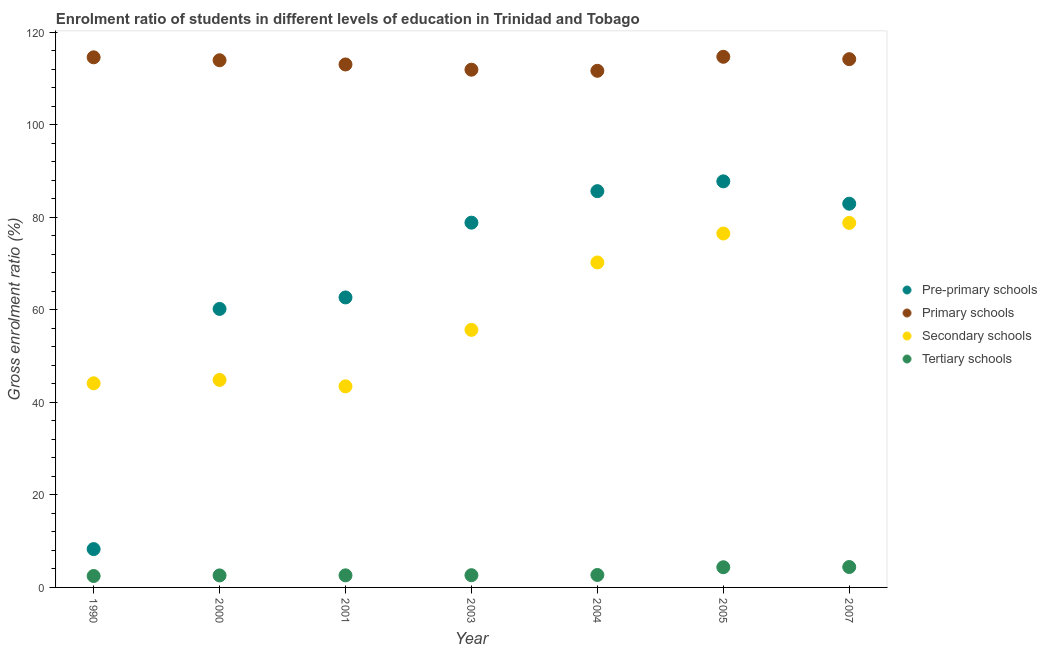How many different coloured dotlines are there?
Ensure brevity in your answer.  4. Is the number of dotlines equal to the number of legend labels?
Ensure brevity in your answer.  Yes. What is the gross enrolment ratio in pre-primary schools in 2001?
Your answer should be very brief. 62.68. Across all years, what is the maximum gross enrolment ratio in primary schools?
Provide a short and direct response. 114.69. Across all years, what is the minimum gross enrolment ratio in pre-primary schools?
Provide a short and direct response. 8.29. In which year was the gross enrolment ratio in tertiary schools maximum?
Give a very brief answer. 2007. In which year was the gross enrolment ratio in secondary schools minimum?
Keep it short and to the point. 2001. What is the total gross enrolment ratio in secondary schools in the graph?
Make the answer very short. 413.62. What is the difference between the gross enrolment ratio in primary schools in 2004 and that in 2007?
Make the answer very short. -2.52. What is the difference between the gross enrolment ratio in tertiary schools in 2001 and the gross enrolment ratio in pre-primary schools in 1990?
Your answer should be very brief. -5.68. What is the average gross enrolment ratio in secondary schools per year?
Provide a short and direct response. 59.09. In the year 2000, what is the difference between the gross enrolment ratio in secondary schools and gross enrolment ratio in pre-primary schools?
Provide a short and direct response. -15.34. In how many years, is the gross enrolment ratio in tertiary schools greater than 104 %?
Ensure brevity in your answer.  0. What is the ratio of the gross enrolment ratio in pre-primary schools in 1990 to that in 2005?
Keep it short and to the point. 0.09. Is the gross enrolment ratio in tertiary schools in 1990 less than that in 2005?
Give a very brief answer. Yes. What is the difference between the highest and the second highest gross enrolment ratio in secondary schools?
Your answer should be very brief. 2.29. What is the difference between the highest and the lowest gross enrolment ratio in primary schools?
Ensure brevity in your answer.  3.03. Is the sum of the gross enrolment ratio in primary schools in 2001 and 2007 greater than the maximum gross enrolment ratio in tertiary schools across all years?
Provide a short and direct response. Yes. Is it the case that in every year, the sum of the gross enrolment ratio in secondary schools and gross enrolment ratio in pre-primary schools is greater than the sum of gross enrolment ratio in primary schools and gross enrolment ratio in tertiary schools?
Ensure brevity in your answer.  No. Is it the case that in every year, the sum of the gross enrolment ratio in pre-primary schools and gross enrolment ratio in primary schools is greater than the gross enrolment ratio in secondary schools?
Your answer should be very brief. Yes. Is the gross enrolment ratio in tertiary schools strictly greater than the gross enrolment ratio in primary schools over the years?
Your response must be concise. No. Is the gross enrolment ratio in tertiary schools strictly less than the gross enrolment ratio in pre-primary schools over the years?
Your answer should be compact. Yes. How many years are there in the graph?
Your answer should be compact. 7. Does the graph contain any zero values?
Provide a succinct answer. No. Where does the legend appear in the graph?
Your answer should be compact. Center right. How many legend labels are there?
Offer a very short reply. 4. How are the legend labels stacked?
Offer a terse response. Vertical. What is the title of the graph?
Give a very brief answer. Enrolment ratio of students in different levels of education in Trinidad and Tobago. Does "Interest Payments" appear as one of the legend labels in the graph?
Offer a terse response. No. What is the label or title of the X-axis?
Give a very brief answer. Year. What is the label or title of the Y-axis?
Make the answer very short. Gross enrolment ratio (%). What is the Gross enrolment ratio (%) in Pre-primary schools in 1990?
Keep it short and to the point. 8.29. What is the Gross enrolment ratio (%) in Primary schools in 1990?
Offer a very short reply. 114.57. What is the Gross enrolment ratio (%) in Secondary schools in 1990?
Keep it short and to the point. 44.12. What is the Gross enrolment ratio (%) of Tertiary schools in 1990?
Offer a very short reply. 2.47. What is the Gross enrolment ratio (%) of Pre-primary schools in 2000?
Make the answer very short. 60.19. What is the Gross enrolment ratio (%) of Primary schools in 2000?
Offer a terse response. 113.94. What is the Gross enrolment ratio (%) in Secondary schools in 2000?
Your answer should be compact. 44.85. What is the Gross enrolment ratio (%) of Tertiary schools in 2000?
Offer a terse response. 2.6. What is the Gross enrolment ratio (%) in Pre-primary schools in 2001?
Your answer should be very brief. 62.68. What is the Gross enrolment ratio (%) of Primary schools in 2001?
Provide a short and direct response. 113.03. What is the Gross enrolment ratio (%) of Secondary schools in 2001?
Your response must be concise. 43.46. What is the Gross enrolment ratio (%) in Tertiary schools in 2001?
Give a very brief answer. 2.61. What is the Gross enrolment ratio (%) of Pre-primary schools in 2003?
Offer a very short reply. 78.84. What is the Gross enrolment ratio (%) in Primary schools in 2003?
Your answer should be very brief. 111.9. What is the Gross enrolment ratio (%) in Secondary schools in 2003?
Your answer should be compact. 55.67. What is the Gross enrolment ratio (%) of Tertiary schools in 2003?
Offer a terse response. 2.64. What is the Gross enrolment ratio (%) of Pre-primary schools in 2004?
Keep it short and to the point. 85.65. What is the Gross enrolment ratio (%) in Primary schools in 2004?
Offer a terse response. 111.66. What is the Gross enrolment ratio (%) in Secondary schools in 2004?
Your answer should be compact. 70.24. What is the Gross enrolment ratio (%) of Tertiary schools in 2004?
Offer a terse response. 2.69. What is the Gross enrolment ratio (%) in Pre-primary schools in 2005?
Your response must be concise. 87.77. What is the Gross enrolment ratio (%) in Primary schools in 2005?
Keep it short and to the point. 114.69. What is the Gross enrolment ratio (%) in Secondary schools in 2005?
Your response must be concise. 76.49. What is the Gross enrolment ratio (%) in Tertiary schools in 2005?
Your response must be concise. 4.36. What is the Gross enrolment ratio (%) in Pre-primary schools in 2007?
Your response must be concise. 82.93. What is the Gross enrolment ratio (%) in Primary schools in 2007?
Offer a very short reply. 114.18. What is the Gross enrolment ratio (%) of Secondary schools in 2007?
Your answer should be compact. 78.78. What is the Gross enrolment ratio (%) of Tertiary schools in 2007?
Provide a succinct answer. 4.41. Across all years, what is the maximum Gross enrolment ratio (%) of Pre-primary schools?
Provide a succinct answer. 87.77. Across all years, what is the maximum Gross enrolment ratio (%) of Primary schools?
Provide a short and direct response. 114.69. Across all years, what is the maximum Gross enrolment ratio (%) of Secondary schools?
Your answer should be very brief. 78.78. Across all years, what is the maximum Gross enrolment ratio (%) in Tertiary schools?
Make the answer very short. 4.41. Across all years, what is the minimum Gross enrolment ratio (%) in Pre-primary schools?
Keep it short and to the point. 8.29. Across all years, what is the minimum Gross enrolment ratio (%) of Primary schools?
Ensure brevity in your answer.  111.66. Across all years, what is the minimum Gross enrolment ratio (%) of Secondary schools?
Make the answer very short. 43.46. Across all years, what is the minimum Gross enrolment ratio (%) of Tertiary schools?
Your answer should be compact. 2.47. What is the total Gross enrolment ratio (%) of Pre-primary schools in the graph?
Give a very brief answer. 466.35. What is the total Gross enrolment ratio (%) in Primary schools in the graph?
Make the answer very short. 793.97. What is the total Gross enrolment ratio (%) in Secondary schools in the graph?
Make the answer very short. 413.62. What is the total Gross enrolment ratio (%) of Tertiary schools in the graph?
Provide a succinct answer. 21.79. What is the difference between the Gross enrolment ratio (%) in Pre-primary schools in 1990 and that in 2000?
Provide a short and direct response. -51.91. What is the difference between the Gross enrolment ratio (%) of Primary schools in 1990 and that in 2000?
Ensure brevity in your answer.  0.63. What is the difference between the Gross enrolment ratio (%) in Secondary schools in 1990 and that in 2000?
Provide a short and direct response. -0.74. What is the difference between the Gross enrolment ratio (%) of Tertiary schools in 1990 and that in 2000?
Your answer should be compact. -0.13. What is the difference between the Gross enrolment ratio (%) of Pre-primary schools in 1990 and that in 2001?
Offer a terse response. -54.39. What is the difference between the Gross enrolment ratio (%) of Primary schools in 1990 and that in 2001?
Offer a terse response. 1.54. What is the difference between the Gross enrolment ratio (%) in Secondary schools in 1990 and that in 2001?
Provide a succinct answer. 0.66. What is the difference between the Gross enrolment ratio (%) in Tertiary schools in 1990 and that in 2001?
Provide a short and direct response. -0.14. What is the difference between the Gross enrolment ratio (%) in Pre-primary schools in 1990 and that in 2003?
Your answer should be very brief. -70.55. What is the difference between the Gross enrolment ratio (%) of Primary schools in 1990 and that in 2003?
Your answer should be very brief. 2.67. What is the difference between the Gross enrolment ratio (%) in Secondary schools in 1990 and that in 2003?
Offer a terse response. -11.55. What is the difference between the Gross enrolment ratio (%) in Tertiary schools in 1990 and that in 2003?
Make the answer very short. -0.18. What is the difference between the Gross enrolment ratio (%) of Pre-primary schools in 1990 and that in 2004?
Your answer should be compact. -77.36. What is the difference between the Gross enrolment ratio (%) of Primary schools in 1990 and that in 2004?
Your answer should be compact. 2.91. What is the difference between the Gross enrolment ratio (%) of Secondary schools in 1990 and that in 2004?
Your response must be concise. -26.12. What is the difference between the Gross enrolment ratio (%) in Tertiary schools in 1990 and that in 2004?
Give a very brief answer. -0.22. What is the difference between the Gross enrolment ratio (%) of Pre-primary schools in 1990 and that in 2005?
Offer a terse response. -79.48. What is the difference between the Gross enrolment ratio (%) in Primary schools in 1990 and that in 2005?
Offer a terse response. -0.12. What is the difference between the Gross enrolment ratio (%) in Secondary schools in 1990 and that in 2005?
Provide a short and direct response. -32.37. What is the difference between the Gross enrolment ratio (%) in Tertiary schools in 1990 and that in 2005?
Your answer should be very brief. -1.89. What is the difference between the Gross enrolment ratio (%) in Pre-primary schools in 1990 and that in 2007?
Your answer should be compact. -74.65. What is the difference between the Gross enrolment ratio (%) of Primary schools in 1990 and that in 2007?
Make the answer very short. 0.4. What is the difference between the Gross enrolment ratio (%) of Secondary schools in 1990 and that in 2007?
Keep it short and to the point. -34.67. What is the difference between the Gross enrolment ratio (%) in Tertiary schools in 1990 and that in 2007?
Your answer should be compact. -1.94. What is the difference between the Gross enrolment ratio (%) of Pre-primary schools in 2000 and that in 2001?
Provide a succinct answer. -2.48. What is the difference between the Gross enrolment ratio (%) of Primary schools in 2000 and that in 2001?
Keep it short and to the point. 0.91. What is the difference between the Gross enrolment ratio (%) in Secondary schools in 2000 and that in 2001?
Your response must be concise. 1.39. What is the difference between the Gross enrolment ratio (%) in Tertiary schools in 2000 and that in 2001?
Your response must be concise. -0.01. What is the difference between the Gross enrolment ratio (%) in Pre-primary schools in 2000 and that in 2003?
Provide a short and direct response. -18.64. What is the difference between the Gross enrolment ratio (%) in Primary schools in 2000 and that in 2003?
Offer a terse response. 2.04. What is the difference between the Gross enrolment ratio (%) in Secondary schools in 2000 and that in 2003?
Provide a succinct answer. -10.81. What is the difference between the Gross enrolment ratio (%) in Tertiary schools in 2000 and that in 2003?
Ensure brevity in your answer.  -0.05. What is the difference between the Gross enrolment ratio (%) in Pre-primary schools in 2000 and that in 2004?
Your response must be concise. -25.45. What is the difference between the Gross enrolment ratio (%) in Primary schools in 2000 and that in 2004?
Offer a very short reply. 2.28. What is the difference between the Gross enrolment ratio (%) of Secondary schools in 2000 and that in 2004?
Provide a short and direct response. -25.38. What is the difference between the Gross enrolment ratio (%) in Tertiary schools in 2000 and that in 2004?
Your answer should be very brief. -0.09. What is the difference between the Gross enrolment ratio (%) of Pre-primary schools in 2000 and that in 2005?
Offer a terse response. -27.57. What is the difference between the Gross enrolment ratio (%) of Primary schools in 2000 and that in 2005?
Make the answer very short. -0.75. What is the difference between the Gross enrolment ratio (%) in Secondary schools in 2000 and that in 2005?
Keep it short and to the point. -31.64. What is the difference between the Gross enrolment ratio (%) in Tertiary schools in 2000 and that in 2005?
Provide a short and direct response. -1.76. What is the difference between the Gross enrolment ratio (%) of Pre-primary schools in 2000 and that in 2007?
Your response must be concise. -22.74. What is the difference between the Gross enrolment ratio (%) in Primary schools in 2000 and that in 2007?
Provide a short and direct response. -0.24. What is the difference between the Gross enrolment ratio (%) in Secondary schools in 2000 and that in 2007?
Offer a terse response. -33.93. What is the difference between the Gross enrolment ratio (%) in Tertiary schools in 2000 and that in 2007?
Make the answer very short. -1.81. What is the difference between the Gross enrolment ratio (%) in Pre-primary schools in 2001 and that in 2003?
Your answer should be compact. -16.16. What is the difference between the Gross enrolment ratio (%) of Primary schools in 2001 and that in 2003?
Keep it short and to the point. 1.13. What is the difference between the Gross enrolment ratio (%) in Secondary schools in 2001 and that in 2003?
Offer a very short reply. -12.21. What is the difference between the Gross enrolment ratio (%) of Tertiary schools in 2001 and that in 2003?
Your answer should be compact. -0.03. What is the difference between the Gross enrolment ratio (%) in Pre-primary schools in 2001 and that in 2004?
Keep it short and to the point. -22.97. What is the difference between the Gross enrolment ratio (%) of Primary schools in 2001 and that in 2004?
Your answer should be compact. 1.37. What is the difference between the Gross enrolment ratio (%) of Secondary schools in 2001 and that in 2004?
Make the answer very short. -26.78. What is the difference between the Gross enrolment ratio (%) of Tertiary schools in 2001 and that in 2004?
Offer a very short reply. -0.08. What is the difference between the Gross enrolment ratio (%) of Pre-primary schools in 2001 and that in 2005?
Your answer should be compact. -25.09. What is the difference between the Gross enrolment ratio (%) of Primary schools in 2001 and that in 2005?
Keep it short and to the point. -1.66. What is the difference between the Gross enrolment ratio (%) in Secondary schools in 2001 and that in 2005?
Your answer should be very brief. -33.03. What is the difference between the Gross enrolment ratio (%) of Tertiary schools in 2001 and that in 2005?
Make the answer very short. -1.75. What is the difference between the Gross enrolment ratio (%) in Pre-primary schools in 2001 and that in 2007?
Offer a very short reply. -20.26. What is the difference between the Gross enrolment ratio (%) in Primary schools in 2001 and that in 2007?
Give a very brief answer. -1.14. What is the difference between the Gross enrolment ratio (%) of Secondary schools in 2001 and that in 2007?
Offer a terse response. -35.32. What is the difference between the Gross enrolment ratio (%) in Tertiary schools in 2001 and that in 2007?
Your answer should be very brief. -1.8. What is the difference between the Gross enrolment ratio (%) of Pre-primary schools in 2003 and that in 2004?
Provide a short and direct response. -6.81. What is the difference between the Gross enrolment ratio (%) in Primary schools in 2003 and that in 2004?
Keep it short and to the point. 0.24. What is the difference between the Gross enrolment ratio (%) of Secondary schools in 2003 and that in 2004?
Your response must be concise. -14.57. What is the difference between the Gross enrolment ratio (%) of Tertiary schools in 2003 and that in 2004?
Provide a succinct answer. -0.05. What is the difference between the Gross enrolment ratio (%) in Pre-primary schools in 2003 and that in 2005?
Your answer should be compact. -8.93. What is the difference between the Gross enrolment ratio (%) of Primary schools in 2003 and that in 2005?
Ensure brevity in your answer.  -2.79. What is the difference between the Gross enrolment ratio (%) of Secondary schools in 2003 and that in 2005?
Your response must be concise. -20.83. What is the difference between the Gross enrolment ratio (%) in Tertiary schools in 2003 and that in 2005?
Ensure brevity in your answer.  -1.72. What is the difference between the Gross enrolment ratio (%) of Pre-primary schools in 2003 and that in 2007?
Keep it short and to the point. -4.1. What is the difference between the Gross enrolment ratio (%) of Primary schools in 2003 and that in 2007?
Provide a succinct answer. -2.28. What is the difference between the Gross enrolment ratio (%) in Secondary schools in 2003 and that in 2007?
Provide a short and direct response. -23.12. What is the difference between the Gross enrolment ratio (%) in Tertiary schools in 2003 and that in 2007?
Provide a succinct answer. -1.77. What is the difference between the Gross enrolment ratio (%) in Pre-primary schools in 2004 and that in 2005?
Provide a succinct answer. -2.12. What is the difference between the Gross enrolment ratio (%) in Primary schools in 2004 and that in 2005?
Ensure brevity in your answer.  -3.03. What is the difference between the Gross enrolment ratio (%) in Secondary schools in 2004 and that in 2005?
Provide a succinct answer. -6.25. What is the difference between the Gross enrolment ratio (%) in Tertiary schools in 2004 and that in 2005?
Your answer should be very brief. -1.67. What is the difference between the Gross enrolment ratio (%) in Pre-primary schools in 2004 and that in 2007?
Provide a short and direct response. 2.71. What is the difference between the Gross enrolment ratio (%) in Primary schools in 2004 and that in 2007?
Your answer should be very brief. -2.52. What is the difference between the Gross enrolment ratio (%) in Secondary schools in 2004 and that in 2007?
Your answer should be compact. -8.54. What is the difference between the Gross enrolment ratio (%) in Tertiary schools in 2004 and that in 2007?
Give a very brief answer. -1.72. What is the difference between the Gross enrolment ratio (%) in Pre-primary schools in 2005 and that in 2007?
Offer a terse response. 4.83. What is the difference between the Gross enrolment ratio (%) of Primary schools in 2005 and that in 2007?
Your answer should be very brief. 0.51. What is the difference between the Gross enrolment ratio (%) in Secondary schools in 2005 and that in 2007?
Offer a terse response. -2.29. What is the difference between the Gross enrolment ratio (%) of Tertiary schools in 2005 and that in 2007?
Give a very brief answer. -0.05. What is the difference between the Gross enrolment ratio (%) of Pre-primary schools in 1990 and the Gross enrolment ratio (%) of Primary schools in 2000?
Keep it short and to the point. -105.65. What is the difference between the Gross enrolment ratio (%) in Pre-primary schools in 1990 and the Gross enrolment ratio (%) in Secondary schools in 2000?
Your answer should be very brief. -36.57. What is the difference between the Gross enrolment ratio (%) in Pre-primary schools in 1990 and the Gross enrolment ratio (%) in Tertiary schools in 2000?
Your response must be concise. 5.69. What is the difference between the Gross enrolment ratio (%) in Primary schools in 1990 and the Gross enrolment ratio (%) in Secondary schools in 2000?
Your answer should be compact. 69.72. What is the difference between the Gross enrolment ratio (%) in Primary schools in 1990 and the Gross enrolment ratio (%) in Tertiary schools in 2000?
Your answer should be compact. 111.98. What is the difference between the Gross enrolment ratio (%) of Secondary schools in 1990 and the Gross enrolment ratio (%) of Tertiary schools in 2000?
Give a very brief answer. 41.52. What is the difference between the Gross enrolment ratio (%) in Pre-primary schools in 1990 and the Gross enrolment ratio (%) in Primary schools in 2001?
Provide a succinct answer. -104.74. What is the difference between the Gross enrolment ratio (%) of Pre-primary schools in 1990 and the Gross enrolment ratio (%) of Secondary schools in 2001?
Offer a very short reply. -35.17. What is the difference between the Gross enrolment ratio (%) of Pre-primary schools in 1990 and the Gross enrolment ratio (%) of Tertiary schools in 2001?
Make the answer very short. 5.68. What is the difference between the Gross enrolment ratio (%) of Primary schools in 1990 and the Gross enrolment ratio (%) of Secondary schools in 2001?
Your response must be concise. 71.11. What is the difference between the Gross enrolment ratio (%) in Primary schools in 1990 and the Gross enrolment ratio (%) in Tertiary schools in 2001?
Keep it short and to the point. 111.96. What is the difference between the Gross enrolment ratio (%) in Secondary schools in 1990 and the Gross enrolment ratio (%) in Tertiary schools in 2001?
Provide a short and direct response. 41.51. What is the difference between the Gross enrolment ratio (%) in Pre-primary schools in 1990 and the Gross enrolment ratio (%) in Primary schools in 2003?
Ensure brevity in your answer.  -103.61. What is the difference between the Gross enrolment ratio (%) of Pre-primary schools in 1990 and the Gross enrolment ratio (%) of Secondary schools in 2003?
Make the answer very short. -47.38. What is the difference between the Gross enrolment ratio (%) in Pre-primary schools in 1990 and the Gross enrolment ratio (%) in Tertiary schools in 2003?
Keep it short and to the point. 5.64. What is the difference between the Gross enrolment ratio (%) in Primary schools in 1990 and the Gross enrolment ratio (%) in Secondary schools in 2003?
Offer a terse response. 58.91. What is the difference between the Gross enrolment ratio (%) in Primary schools in 1990 and the Gross enrolment ratio (%) in Tertiary schools in 2003?
Keep it short and to the point. 111.93. What is the difference between the Gross enrolment ratio (%) of Secondary schools in 1990 and the Gross enrolment ratio (%) of Tertiary schools in 2003?
Your answer should be very brief. 41.47. What is the difference between the Gross enrolment ratio (%) of Pre-primary schools in 1990 and the Gross enrolment ratio (%) of Primary schools in 2004?
Your answer should be compact. -103.37. What is the difference between the Gross enrolment ratio (%) of Pre-primary schools in 1990 and the Gross enrolment ratio (%) of Secondary schools in 2004?
Your response must be concise. -61.95. What is the difference between the Gross enrolment ratio (%) in Pre-primary schools in 1990 and the Gross enrolment ratio (%) in Tertiary schools in 2004?
Give a very brief answer. 5.6. What is the difference between the Gross enrolment ratio (%) of Primary schools in 1990 and the Gross enrolment ratio (%) of Secondary schools in 2004?
Ensure brevity in your answer.  44.33. What is the difference between the Gross enrolment ratio (%) of Primary schools in 1990 and the Gross enrolment ratio (%) of Tertiary schools in 2004?
Provide a short and direct response. 111.88. What is the difference between the Gross enrolment ratio (%) of Secondary schools in 1990 and the Gross enrolment ratio (%) of Tertiary schools in 2004?
Keep it short and to the point. 41.43. What is the difference between the Gross enrolment ratio (%) of Pre-primary schools in 1990 and the Gross enrolment ratio (%) of Primary schools in 2005?
Provide a short and direct response. -106.4. What is the difference between the Gross enrolment ratio (%) in Pre-primary schools in 1990 and the Gross enrolment ratio (%) in Secondary schools in 2005?
Your answer should be very brief. -68.21. What is the difference between the Gross enrolment ratio (%) in Pre-primary schools in 1990 and the Gross enrolment ratio (%) in Tertiary schools in 2005?
Your response must be concise. 3.92. What is the difference between the Gross enrolment ratio (%) in Primary schools in 1990 and the Gross enrolment ratio (%) in Secondary schools in 2005?
Offer a very short reply. 38.08. What is the difference between the Gross enrolment ratio (%) of Primary schools in 1990 and the Gross enrolment ratio (%) of Tertiary schools in 2005?
Provide a short and direct response. 110.21. What is the difference between the Gross enrolment ratio (%) in Secondary schools in 1990 and the Gross enrolment ratio (%) in Tertiary schools in 2005?
Provide a succinct answer. 39.76. What is the difference between the Gross enrolment ratio (%) of Pre-primary schools in 1990 and the Gross enrolment ratio (%) of Primary schools in 2007?
Provide a succinct answer. -105.89. What is the difference between the Gross enrolment ratio (%) of Pre-primary schools in 1990 and the Gross enrolment ratio (%) of Secondary schools in 2007?
Keep it short and to the point. -70.5. What is the difference between the Gross enrolment ratio (%) in Pre-primary schools in 1990 and the Gross enrolment ratio (%) in Tertiary schools in 2007?
Provide a succinct answer. 3.87. What is the difference between the Gross enrolment ratio (%) in Primary schools in 1990 and the Gross enrolment ratio (%) in Secondary schools in 2007?
Give a very brief answer. 35.79. What is the difference between the Gross enrolment ratio (%) in Primary schools in 1990 and the Gross enrolment ratio (%) in Tertiary schools in 2007?
Ensure brevity in your answer.  110.16. What is the difference between the Gross enrolment ratio (%) in Secondary schools in 1990 and the Gross enrolment ratio (%) in Tertiary schools in 2007?
Provide a short and direct response. 39.71. What is the difference between the Gross enrolment ratio (%) in Pre-primary schools in 2000 and the Gross enrolment ratio (%) in Primary schools in 2001?
Your response must be concise. -52.84. What is the difference between the Gross enrolment ratio (%) of Pre-primary schools in 2000 and the Gross enrolment ratio (%) of Secondary schools in 2001?
Offer a very short reply. 16.73. What is the difference between the Gross enrolment ratio (%) in Pre-primary schools in 2000 and the Gross enrolment ratio (%) in Tertiary schools in 2001?
Offer a very short reply. 57.58. What is the difference between the Gross enrolment ratio (%) of Primary schools in 2000 and the Gross enrolment ratio (%) of Secondary schools in 2001?
Offer a terse response. 70.48. What is the difference between the Gross enrolment ratio (%) in Primary schools in 2000 and the Gross enrolment ratio (%) in Tertiary schools in 2001?
Your answer should be compact. 111.33. What is the difference between the Gross enrolment ratio (%) of Secondary schools in 2000 and the Gross enrolment ratio (%) of Tertiary schools in 2001?
Give a very brief answer. 42.24. What is the difference between the Gross enrolment ratio (%) of Pre-primary schools in 2000 and the Gross enrolment ratio (%) of Primary schools in 2003?
Offer a very short reply. -51.71. What is the difference between the Gross enrolment ratio (%) in Pre-primary schools in 2000 and the Gross enrolment ratio (%) in Secondary schools in 2003?
Provide a succinct answer. 4.53. What is the difference between the Gross enrolment ratio (%) in Pre-primary schools in 2000 and the Gross enrolment ratio (%) in Tertiary schools in 2003?
Provide a short and direct response. 57.55. What is the difference between the Gross enrolment ratio (%) of Primary schools in 2000 and the Gross enrolment ratio (%) of Secondary schools in 2003?
Give a very brief answer. 58.27. What is the difference between the Gross enrolment ratio (%) of Primary schools in 2000 and the Gross enrolment ratio (%) of Tertiary schools in 2003?
Offer a terse response. 111.29. What is the difference between the Gross enrolment ratio (%) of Secondary schools in 2000 and the Gross enrolment ratio (%) of Tertiary schools in 2003?
Make the answer very short. 42.21. What is the difference between the Gross enrolment ratio (%) of Pre-primary schools in 2000 and the Gross enrolment ratio (%) of Primary schools in 2004?
Make the answer very short. -51.46. What is the difference between the Gross enrolment ratio (%) of Pre-primary schools in 2000 and the Gross enrolment ratio (%) of Secondary schools in 2004?
Provide a short and direct response. -10.05. What is the difference between the Gross enrolment ratio (%) of Pre-primary schools in 2000 and the Gross enrolment ratio (%) of Tertiary schools in 2004?
Provide a short and direct response. 57.5. What is the difference between the Gross enrolment ratio (%) in Primary schools in 2000 and the Gross enrolment ratio (%) in Secondary schools in 2004?
Offer a terse response. 43.7. What is the difference between the Gross enrolment ratio (%) in Primary schools in 2000 and the Gross enrolment ratio (%) in Tertiary schools in 2004?
Offer a terse response. 111.25. What is the difference between the Gross enrolment ratio (%) of Secondary schools in 2000 and the Gross enrolment ratio (%) of Tertiary schools in 2004?
Offer a very short reply. 42.16. What is the difference between the Gross enrolment ratio (%) in Pre-primary schools in 2000 and the Gross enrolment ratio (%) in Primary schools in 2005?
Make the answer very short. -54.49. What is the difference between the Gross enrolment ratio (%) of Pre-primary schools in 2000 and the Gross enrolment ratio (%) of Secondary schools in 2005?
Your response must be concise. -16.3. What is the difference between the Gross enrolment ratio (%) in Pre-primary schools in 2000 and the Gross enrolment ratio (%) in Tertiary schools in 2005?
Ensure brevity in your answer.  55.83. What is the difference between the Gross enrolment ratio (%) of Primary schools in 2000 and the Gross enrolment ratio (%) of Secondary schools in 2005?
Your response must be concise. 37.45. What is the difference between the Gross enrolment ratio (%) in Primary schools in 2000 and the Gross enrolment ratio (%) in Tertiary schools in 2005?
Ensure brevity in your answer.  109.58. What is the difference between the Gross enrolment ratio (%) in Secondary schools in 2000 and the Gross enrolment ratio (%) in Tertiary schools in 2005?
Offer a very short reply. 40.49. What is the difference between the Gross enrolment ratio (%) of Pre-primary schools in 2000 and the Gross enrolment ratio (%) of Primary schools in 2007?
Ensure brevity in your answer.  -53.98. What is the difference between the Gross enrolment ratio (%) in Pre-primary schools in 2000 and the Gross enrolment ratio (%) in Secondary schools in 2007?
Offer a very short reply. -18.59. What is the difference between the Gross enrolment ratio (%) of Pre-primary schools in 2000 and the Gross enrolment ratio (%) of Tertiary schools in 2007?
Your answer should be compact. 55.78. What is the difference between the Gross enrolment ratio (%) in Primary schools in 2000 and the Gross enrolment ratio (%) in Secondary schools in 2007?
Your answer should be compact. 35.15. What is the difference between the Gross enrolment ratio (%) in Primary schools in 2000 and the Gross enrolment ratio (%) in Tertiary schools in 2007?
Offer a very short reply. 109.53. What is the difference between the Gross enrolment ratio (%) of Secondary schools in 2000 and the Gross enrolment ratio (%) of Tertiary schools in 2007?
Ensure brevity in your answer.  40.44. What is the difference between the Gross enrolment ratio (%) in Pre-primary schools in 2001 and the Gross enrolment ratio (%) in Primary schools in 2003?
Provide a succinct answer. -49.22. What is the difference between the Gross enrolment ratio (%) in Pre-primary schools in 2001 and the Gross enrolment ratio (%) in Secondary schools in 2003?
Your answer should be compact. 7.01. What is the difference between the Gross enrolment ratio (%) in Pre-primary schools in 2001 and the Gross enrolment ratio (%) in Tertiary schools in 2003?
Your answer should be compact. 60.03. What is the difference between the Gross enrolment ratio (%) of Primary schools in 2001 and the Gross enrolment ratio (%) of Secondary schools in 2003?
Keep it short and to the point. 57.36. What is the difference between the Gross enrolment ratio (%) of Primary schools in 2001 and the Gross enrolment ratio (%) of Tertiary schools in 2003?
Your answer should be very brief. 110.39. What is the difference between the Gross enrolment ratio (%) in Secondary schools in 2001 and the Gross enrolment ratio (%) in Tertiary schools in 2003?
Give a very brief answer. 40.82. What is the difference between the Gross enrolment ratio (%) in Pre-primary schools in 2001 and the Gross enrolment ratio (%) in Primary schools in 2004?
Make the answer very short. -48.98. What is the difference between the Gross enrolment ratio (%) of Pre-primary schools in 2001 and the Gross enrolment ratio (%) of Secondary schools in 2004?
Offer a very short reply. -7.56. What is the difference between the Gross enrolment ratio (%) in Pre-primary schools in 2001 and the Gross enrolment ratio (%) in Tertiary schools in 2004?
Offer a terse response. 59.99. What is the difference between the Gross enrolment ratio (%) of Primary schools in 2001 and the Gross enrolment ratio (%) of Secondary schools in 2004?
Provide a succinct answer. 42.79. What is the difference between the Gross enrolment ratio (%) in Primary schools in 2001 and the Gross enrolment ratio (%) in Tertiary schools in 2004?
Make the answer very short. 110.34. What is the difference between the Gross enrolment ratio (%) of Secondary schools in 2001 and the Gross enrolment ratio (%) of Tertiary schools in 2004?
Ensure brevity in your answer.  40.77. What is the difference between the Gross enrolment ratio (%) of Pre-primary schools in 2001 and the Gross enrolment ratio (%) of Primary schools in 2005?
Ensure brevity in your answer.  -52.01. What is the difference between the Gross enrolment ratio (%) of Pre-primary schools in 2001 and the Gross enrolment ratio (%) of Secondary schools in 2005?
Ensure brevity in your answer.  -13.82. What is the difference between the Gross enrolment ratio (%) in Pre-primary schools in 2001 and the Gross enrolment ratio (%) in Tertiary schools in 2005?
Give a very brief answer. 58.32. What is the difference between the Gross enrolment ratio (%) of Primary schools in 2001 and the Gross enrolment ratio (%) of Secondary schools in 2005?
Keep it short and to the point. 36.54. What is the difference between the Gross enrolment ratio (%) in Primary schools in 2001 and the Gross enrolment ratio (%) in Tertiary schools in 2005?
Provide a succinct answer. 108.67. What is the difference between the Gross enrolment ratio (%) in Secondary schools in 2001 and the Gross enrolment ratio (%) in Tertiary schools in 2005?
Your answer should be compact. 39.1. What is the difference between the Gross enrolment ratio (%) in Pre-primary schools in 2001 and the Gross enrolment ratio (%) in Primary schools in 2007?
Offer a very short reply. -51.5. What is the difference between the Gross enrolment ratio (%) in Pre-primary schools in 2001 and the Gross enrolment ratio (%) in Secondary schools in 2007?
Your answer should be compact. -16.11. What is the difference between the Gross enrolment ratio (%) in Pre-primary schools in 2001 and the Gross enrolment ratio (%) in Tertiary schools in 2007?
Your response must be concise. 58.27. What is the difference between the Gross enrolment ratio (%) of Primary schools in 2001 and the Gross enrolment ratio (%) of Secondary schools in 2007?
Give a very brief answer. 34.25. What is the difference between the Gross enrolment ratio (%) in Primary schools in 2001 and the Gross enrolment ratio (%) in Tertiary schools in 2007?
Your response must be concise. 108.62. What is the difference between the Gross enrolment ratio (%) in Secondary schools in 2001 and the Gross enrolment ratio (%) in Tertiary schools in 2007?
Give a very brief answer. 39.05. What is the difference between the Gross enrolment ratio (%) of Pre-primary schools in 2003 and the Gross enrolment ratio (%) of Primary schools in 2004?
Offer a very short reply. -32.82. What is the difference between the Gross enrolment ratio (%) of Pre-primary schools in 2003 and the Gross enrolment ratio (%) of Secondary schools in 2004?
Offer a very short reply. 8.6. What is the difference between the Gross enrolment ratio (%) of Pre-primary schools in 2003 and the Gross enrolment ratio (%) of Tertiary schools in 2004?
Give a very brief answer. 76.15. What is the difference between the Gross enrolment ratio (%) in Primary schools in 2003 and the Gross enrolment ratio (%) in Secondary schools in 2004?
Give a very brief answer. 41.66. What is the difference between the Gross enrolment ratio (%) in Primary schools in 2003 and the Gross enrolment ratio (%) in Tertiary schools in 2004?
Offer a very short reply. 109.21. What is the difference between the Gross enrolment ratio (%) in Secondary schools in 2003 and the Gross enrolment ratio (%) in Tertiary schools in 2004?
Offer a terse response. 52.98. What is the difference between the Gross enrolment ratio (%) in Pre-primary schools in 2003 and the Gross enrolment ratio (%) in Primary schools in 2005?
Keep it short and to the point. -35.85. What is the difference between the Gross enrolment ratio (%) in Pre-primary schools in 2003 and the Gross enrolment ratio (%) in Secondary schools in 2005?
Keep it short and to the point. 2.34. What is the difference between the Gross enrolment ratio (%) in Pre-primary schools in 2003 and the Gross enrolment ratio (%) in Tertiary schools in 2005?
Keep it short and to the point. 74.47. What is the difference between the Gross enrolment ratio (%) of Primary schools in 2003 and the Gross enrolment ratio (%) of Secondary schools in 2005?
Provide a succinct answer. 35.41. What is the difference between the Gross enrolment ratio (%) in Primary schools in 2003 and the Gross enrolment ratio (%) in Tertiary schools in 2005?
Your answer should be very brief. 107.54. What is the difference between the Gross enrolment ratio (%) of Secondary schools in 2003 and the Gross enrolment ratio (%) of Tertiary schools in 2005?
Your answer should be compact. 51.31. What is the difference between the Gross enrolment ratio (%) in Pre-primary schools in 2003 and the Gross enrolment ratio (%) in Primary schools in 2007?
Your answer should be compact. -35.34. What is the difference between the Gross enrolment ratio (%) in Pre-primary schools in 2003 and the Gross enrolment ratio (%) in Secondary schools in 2007?
Ensure brevity in your answer.  0.05. What is the difference between the Gross enrolment ratio (%) of Pre-primary schools in 2003 and the Gross enrolment ratio (%) of Tertiary schools in 2007?
Provide a succinct answer. 74.42. What is the difference between the Gross enrolment ratio (%) in Primary schools in 2003 and the Gross enrolment ratio (%) in Secondary schools in 2007?
Your answer should be very brief. 33.12. What is the difference between the Gross enrolment ratio (%) in Primary schools in 2003 and the Gross enrolment ratio (%) in Tertiary schools in 2007?
Make the answer very short. 107.49. What is the difference between the Gross enrolment ratio (%) in Secondary schools in 2003 and the Gross enrolment ratio (%) in Tertiary schools in 2007?
Offer a very short reply. 51.26. What is the difference between the Gross enrolment ratio (%) in Pre-primary schools in 2004 and the Gross enrolment ratio (%) in Primary schools in 2005?
Your answer should be very brief. -29.04. What is the difference between the Gross enrolment ratio (%) of Pre-primary schools in 2004 and the Gross enrolment ratio (%) of Secondary schools in 2005?
Keep it short and to the point. 9.15. What is the difference between the Gross enrolment ratio (%) of Pre-primary schools in 2004 and the Gross enrolment ratio (%) of Tertiary schools in 2005?
Your answer should be compact. 81.29. What is the difference between the Gross enrolment ratio (%) of Primary schools in 2004 and the Gross enrolment ratio (%) of Secondary schools in 2005?
Ensure brevity in your answer.  35.17. What is the difference between the Gross enrolment ratio (%) of Primary schools in 2004 and the Gross enrolment ratio (%) of Tertiary schools in 2005?
Offer a terse response. 107.3. What is the difference between the Gross enrolment ratio (%) in Secondary schools in 2004 and the Gross enrolment ratio (%) in Tertiary schools in 2005?
Your response must be concise. 65.88. What is the difference between the Gross enrolment ratio (%) of Pre-primary schools in 2004 and the Gross enrolment ratio (%) of Primary schools in 2007?
Offer a very short reply. -28.53. What is the difference between the Gross enrolment ratio (%) of Pre-primary schools in 2004 and the Gross enrolment ratio (%) of Secondary schools in 2007?
Keep it short and to the point. 6.86. What is the difference between the Gross enrolment ratio (%) of Pre-primary schools in 2004 and the Gross enrolment ratio (%) of Tertiary schools in 2007?
Keep it short and to the point. 81.24. What is the difference between the Gross enrolment ratio (%) in Primary schools in 2004 and the Gross enrolment ratio (%) in Secondary schools in 2007?
Ensure brevity in your answer.  32.87. What is the difference between the Gross enrolment ratio (%) in Primary schools in 2004 and the Gross enrolment ratio (%) in Tertiary schools in 2007?
Ensure brevity in your answer.  107.25. What is the difference between the Gross enrolment ratio (%) in Secondary schools in 2004 and the Gross enrolment ratio (%) in Tertiary schools in 2007?
Offer a terse response. 65.83. What is the difference between the Gross enrolment ratio (%) of Pre-primary schools in 2005 and the Gross enrolment ratio (%) of Primary schools in 2007?
Offer a terse response. -26.41. What is the difference between the Gross enrolment ratio (%) of Pre-primary schools in 2005 and the Gross enrolment ratio (%) of Secondary schools in 2007?
Your response must be concise. 8.98. What is the difference between the Gross enrolment ratio (%) in Pre-primary schools in 2005 and the Gross enrolment ratio (%) in Tertiary schools in 2007?
Your response must be concise. 83.35. What is the difference between the Gross enrolment ratio (%) of Primary schools in 2005 and the Gross enrolment ratio (%) of Secondary schools in 2007?
Your answer should be compact. 35.9. What is the difference between the Gross enrolment ratio (%) of Primary schools in 2005 and the Gross enrolment ratio (%) of Tertiary schools in 2007?
Offer a very short reply. 110.28. What is the difference between the Gross enrolment ratio (%) in Secondary schools in 2005 and the Gross enrolment ratio (%) in Tertiary schools in 2007?
Your answer should be compact. 72.08. What is the average Gross enrolment ratio (%) in Pre-primary schools per year?
Your answer should be compact. 66.62. What is the average Gross enrolment ratio (%) of Primary schools per year?
Provide a succinct answer. 113.42. What is the average Gross enrolment ratio (%) of Secondary schools per year?
Your response must be concise. 59.09. What is the average Gross enrolment ratio (%) in Tertiary schools per year?
Ensure brevity in your answer.  3.11. In the year 1990, what is the difference between the Gross enrolment ratio (%) of Pre-primary schools and Gross enrolment ratio (%) of Primary schools?
Your response must be concise. -106.29. In the year 1990, what is the difference between the Gross enrolment ratio (%) of Pre-primary schools and Gross enrolment ratio (%) of Secondary schools?
Offer a terse response. -35.83. In the year 1990, what is the difference between the Gross enrolment ratio (%) of Pre-primary schools and Gross enrolment ratio (%) of Tertiary schools?
Your response must be concise. 5.82. In the year 1990, what is the difference between the Gross enrolment ratio (%) in Primary schools and Gross enrolment ratio (%) in Secondary schools?
Offer a terse response. 70.45. In the year 1990, what is the difference between the Gross enrolment ratio (%) of Primary schools and Gross enrolment ratio (%) of Tertiary schools?
Provide a succinct answer. 112.1. In the year 1990, what is the difference between the Gross enrolment ratio (%) of Secondary schools and Gross enrolment ratio (%) of Tertiary schools?
Offer a very short reply. 41.65. In the year 2000, what is the difference between the Gross enrolment ratio (%) in Pre-primary schools and Gross enrolment ratio (%) in Primary schools?
Your answer should be compact. -53.74. In the year 2000, what is the difference between the Gross enrolment ratio (%) in Pre-primary schools and Gross enrolment ratio (%) in Secondary schools?
Give a very brief answer. 15.34. In the year 2000, what is the difference between the Gross enrolment ratio (%) in Pre-primary schools and Gross enrolment ratio (%) in Tertiary schools?
Your response must be concise. 57.6. In the year 2000, what is the difference between the Gross enrolment ratio (%) of Primary schools and Gross enrolment ratio (%) of Secondary schools?
Give a very brief answer. 69.08. In the year 2000, what is the difference between the Gross enrolment ratio (%) of Primary schools and Gross enrolment ratio (%) of Tertiary schools?
Make the answer very short. 111.34. In the year 2000, what is the difference between the Gross enrolment ratio (%) in Secondary schools and Gross enrolment ratio (%) in Tertiary schools?
Provide a succinct answer. 42.26. In the year 2001, what is the difference between the Gross enrolment ratio (%) in Pre-primary schools and Gross enrolment ratio (%) in Primary schools?
Your answer should be compact. -50.35. In the year 2001, what is the difference between the Gross enrolment ratio (%) in Pre-primary schools and Gross enrolment ratio (%) in Secondary schools?
Make the answer very short. 19.22. In the year 2001, what is the difference between the Gross enrolment ratio (%) of Pre-primary schools and Gross enrolment ratio (%) of Tertiary schools?
Offer a terse response. 60.07. In the year 2001, what is the difference between the Gross enrolment ratio (%) in Primary schools and Gross enrolment ratio (%) in Secondary schools?
Your response must be concise. 69.57. In the year 2001, what is the difference between the Gross enrolment ratio (%) of Primary schools and Gross enrolment ratio (%) of Tertiary schools?
Offer a terse response. 110.42. In the year 2001, what is the difference between the Gross enrolment ratio (%) in Secondary schools and Gross enrolment ratio (%) in Tertiary schools?
Offer a very short reply. 40.85. In the year 2003, what is the difference between the Gross enrolment ratio (%) of Pre-primary schools and Gross enrolment ratio (%) of Primary schools?
Keep it short and to the point. -33.06. In the year 2003, what is the difference between the Gross enrolment ratio (%) of Pre-primary schools and Gross enrolment ratio (%) of Secondary schools?
Offer a very short reply. 23.17. In the year 2003, what is the difference between the Gross enrolment ratio (%) in Pre-primary schools and Gross enrolment ratio (%) in Tertiary schools?
Offer a terse response. 76.19. In the year 2003, what is the difference between the Gross enrolment ratio (%) in Primary schools and Gross enrolment ratio (%) in Secondary schools?
Make the answer very short. 56.23. In the year 2003, what is the difference between the Gross enrolment ratio (%) in Primary schools and Gross enrolment ratio (%) in Tertiary schools?
Provide a succinct answer. 109.26. In the year 2003, what is the difference between the Gross enrolment ratio (%) of Secondary schools and Gross enrolment ratio (%) of Tertiary schools?
Make the answer very short. 53.02. In the year 2004, what is the difference between the Gross enrolment ratio (%) of Pre-primary schools and Gross enrolment ratio (%) of Primary schools?
Offer a very short reply. -26.01. In the year 2004, what is the difference between the Gross enrolment ratio (%) of Pre-primary schools and Gross enrolment ratio (%) of Secondary schools?
Your answer should be very brief. 15.41. In the year 2004, what is the difference between the Gross enrolment ratio (%) of Pre-primary schools and Gross enrolment ratio (%) of Tertiary schools?
Ensure brevity in your answer.  82.96. In the year 2004, what is the difference between the Gross enrolment ratio (%) of Primary schools and Gross enrolment ratio (%) of Secondary schools?
Offer a very short reply. 41.42. In the year 2004, what is the difference between the Gross enrolment ratio (%) of Primary schools and Gross enrolment ratio (%) of Tertiary schools?
Provide a short and direct response. 108.97. In the year 2004, what is the difference between the Gross enrolment ratio (%) of Secondary schools and Gross enrolment ratio (%) of Tertiary schools?
Keep it short and to the point. 67.55. In the year 2005, what is the difference between the Gross enrolment ratio (%) of Pre-primary schools and Gross enrolment ratio (%) of Primary schools?
Provide a short and direct response. -26.92. In the year 2005, what is the difference between the Gross enrolment ratio (%) of Pre-primary schools and Gross enrolment ratio (%) of Secondary schools?
Your answer should be compact. 11.27. In the year 2005, what is the difference between the Gross enrolment ratio (%) of Pre-primary schools and Gross enrolment ratio (%) of Tertiary schools?
Keep it short and to the point. 83.4. In the year 2005, what is the difference between the Gross enrolment ratio (%) of Primary schools and Gross enrolment ratio (%) of Secondary schools?
Offer a very short reply. 38.2. In the year 2005, what is the difference between the Gross enrolment ratio (%) of Primary schools and Gross enrolment ratio (%) of Tertiary schools?
Offer a terse response. 110.33. In the year 2005, what is the difference between the Gross enrolment ratio (%) of Secondary schools and Gross enrolment ratio (%) of Tertiary schools?
Ensure brevity in your answer.  72.13. In the year 2007, what is the difference between the Gross enrolment ratio (%) of Pre-primary schools and Gross enrolment ratio (%) of Primary schools?
Your answer should be compact. -31.24. In the year 2007, what is the difference between the Gross enrolment ratio (%) in Pre-primary schools and Gross enrolment ratio (%) in Secondary schools?
Offer a very short reply. 4.15. In the year 2007, what is the difference between the Gross enrolment ratio (%) of Pre-primary schools and Gross enrolment ratio (%) of Tertiary schools?
Ensure brevity in your answer.  78.52. In the year 2007, what is the difference between the Gross enrolment ratio (%) in Primary schools and Gross enrolment ratio (%) in Secondary schools?
Provide a short and direct response. 35.39. In the year 2007, what is the difference between the Gross enrolment ratio (%) in Primary schools and Gross enrolment ratio (%) in Tertiary schools?
Offer a terse response. 109.76. In the year 2007, what is the difference between the Gross enrolment ratio (%) in Secondary schools and Gross enrolment ratio (%) in Tertiary schools?
Provide a succinct answer. 74.37. What is the ratio of the Gross enrolment ratio (%) in Pre-primary schools in 1990 to that in 2000?
Your answer should be very brief. 0.14. What is the ratio of the Gross enrolment ratio (%) of Primary schools in 1990 to that in 2000?
Your response must be concise. 1.01. What is the ratio of the Gross enrolment ratio (%) in Secondary schools in 1990 to that in 2000?
Make the answer very short. 0.98. What is the ratio of the Gross enrolment ratio (%) of Tertiary schools in 1990 to that in 2000?
Your answer should be very brief. 0.95. What is the ratio of the Gross enrolment ratio (%) in Pre-primary schools in 1990 to that in 2001?
Ensure brevity in your answer.  0.13. What is the ratio of the Gross enrolment ratio (%) of Primary schools in 1990 to that in 2001?
Your answer should be compact. 1.01. What is the ratio of the Gross enrolment ratio (%) in Secondary schools in 1990 to that in 2001?
Offer a very short reply. 1.02. What is the ratio of the Gross enrolment ratio (%) in Tertiary schools in 1990 to that in 2001?
Your answer should be compact. 0.95. What is the ratio of the Gross enrolment ratio (%) of Pre-primary schools in 1990 to that in 2003?
Give a very brief answer. 0.11. What is the ratio of the Gross enrolment ratio (%) of Primary schools in 1990 to that in 2003?
Offer a very short reply. 1.02. What is the ratio of the Gross enrolment ratio (%) in Secondary schools in 1990 to that in 2003?
Offer a very short reply. 0.79. What is the ratio of the Gross enrolment ratio (%) in Tertiary schools in 1990 to that in 2003?
Your response must be concise. 0.93. What is the ratio of the Gross enrolment ratio (%) of Pre-primary schools in 1990 to that in 2004?
Keep it short and to the point. 0.1. What is the ratio of the Gross enrolment ratio (%) of Primary schools in 1990 to that in 2004?
Provide a short and direct response. 1.03. What is the ratio of the Gross enrolment ratio (%) in Secondary schools in 1990 to that in 2004?
Provide a short and direct response. 0.63. What is the ratio of the Gross enrolment ratio (%) of Tertiary schools in 1990 to that in 2004?
Offer a very short reply. 0.92. What is the ratio of the Gross enrolment ratio (%) of Pre-primary schools in 1990 to that in 2005?
Your answer should be compact. 0.09. What is the ratio of the Gross enrolment ratio (%) of Secondary schools in 1990 to that in 2005?
Provide a short and direct response. 0.58. What is the ratio of the Gross enrolment ratio (%) in Tertiary schools in 1990 to that in 2005?
Give a very brief answer. 0.57. What is the ratio of the Gross enrolment ratio (%) in Pre-primary schools in 1990 to that in 2007?
Offer a very short reply. 0.1. What is the ratio of the Gross enrolment ratio (%) of Primary schools in 1990 to that in 2007?
Your answer should be very brief. 1. What is the ratio of the Gross enrolment ratio (%) in Secondary schools in 1990 to that in 2007?
Offer a terse response. 0.56. What is the ratio of the Gross enrolment ratio (%) in Tertiary schools in 1990 to that in 2007?
Make the answer very short. 0.56. What is the ratio of the Gross enrolment ratio (%) in Pre-primary schools in 2000 to that in 2001?
Keep it short and to the point. 0.96. What is the ratio of the Gross enrolment ratio (%) of Primary schools in 2000 to that in 2001?
Give a very brief answer. 1.01. What is the ratio of the Gross enrolment ratio (%) in Secondary schools in 2000 to that in 2001?
Make the answer very short. 1.03. What is the ratio of the Gross enrolment ratio (%) of Tertiary schools in 2000 to that in 2001?
Make the answer very short. 1. What is the ratio of the Gross enrolment ratio (%) in Pre-primary schools in 2000 to that in 2003?
Provide a short and direct response. 0.76. What is the ratio of the Gross enrolment ratio (%) of Primary schools in 2000 to that in 2003?
Provide a succinct answer. 1.02. What is the ratio of the Gross enrolment ratio (%) of Secondary schools in 2000 to that in 2003?
Give a very brief answer. 0.81. What is the ratio of the Gross enrolment ratio (%) in Tertiary schools in 2000 to that in 2003?
Your response must be concise. 0.98. What is the ratio of the Gross enrolment ratio (%) in Pre-primary schools in 2000 to that in 2004?
Your answer should be very brief. 0.7. What is the ratio of the Gross enrolment ratio (%) of Primary schools in 2000 to that in 2004?
Offer a very short reply. 1.02. What is the ratio of the Gross enrolment ratio (%) in Secondary schools in 2000 to that in 2004?
Your response must be concise. 0.64. What is the ratio of the Gross enrolment ratio (%) of Tertiary schools in 2000 to that in 2004?
Offer a very short reply. 0.97. What is the ratio of the Gross enrolment ratio (%) of Pre-primary schools in 2000 to that in 2005?
Give a very brief answer. 0.69. What is the ratio of the Gross enrolment ratio (%) of Secondary schools in 2000 to that in 2005?
Offer a very short reply. 0.59. What is the ratio of the Gross enrolment ratio (%) in Tertiary schools in 2000 to that in 2005?
Offer a terse response. 0.6. What is the ratio of the Gross enrolment ratio (%) in Pre-primary schools in 2000 to that in 2007?
Ensure brevity in your answer.  0.73. What is the ratio of the Gross enrolment ratio (%) of Primary schools in 2000 to that in 2007?
Provide a succinct answer. 1. What is the ratio of the Gross enrolment ratio (%) in Secondary schools in 2000 to that in 2007?
Your answer should be compact. 0.57. What is the ratio of the Gross enrolment ratio (%) in Tertiary schools in 2000 to that in 2007?
Offer a terse response. 0.59. What is the ratio of the Gross enrolment ratio (%) in Pre-primary schools in 2001 to that in 2003?
Keep it short and to the point. 0.8. What is the ratio of the Gross enrolment ratio (%) in Primary schools in 2001 to that in 2003?
Your response must be concise. 1.01. What is the ratio of the Gross enrolment ratio (%) of Secondary schools in 2001 to that in 2003?
Offer a terse response. 0.78. What is the ratio of the Gross enrolment ratio (%) of Tertiary schools in 2001 to that in 2003?
Your answer should be compact. 0.99. What is the ratio of the Gross enrolment ratio (%) of Pre-primary schools in 2001 to that in 2004?
Your response must be concise. 0.73. What is the ratio of the Gross enrolment ratio (%) of Primary schools in 2001 to that in 2004?
Your response must be concise. 1.01. What is the ratio of the Gross enrolment ratio (%) of Secondary schools in 2001 to that in 2004?
Your response must be concise. 0.62. What is the ratio of the Gross enrolment ratio (%) in Tertiary schools in 2001 to that in 2004?
Provide a succinct answer. 0.97. What is the ratio of the Gross enrolment ratio (%) of Pre-primary schools in 2001 to that in 2005?
Keep it short and to the point. 0.71. What is the ratio of the Gross enrolment ratio (%) in Primary schools in 2001 to that in 2005?
Ensure brevity in your answer.  0.99. What is the ratio of the Gross enrolment ratio (%) of Secondary schools in 2001 to that in 2005?
Ensure brevity in your answer.  0.57. What is the ratio of the Gross enrolment ratio (%) in Tertiary schools in 2001 to that in 2005?
Your answer should be very brief. 0.6. What is the ratio of the Gross enrolment ratio (%) of Pre-primary schools in 2001 to that in 2007?
Your response must be concise. 0.76. What is the ratio of the Gross enrolment ratio (%) of Primary schools in 2001 to that in 2007?
Offer a terse response. 0.99. What is the ratio of the Gross enrolment ratio (%) in Secondary schools in 2001 to that in 2007?
Offer a terse response. 0.55. What is the ratio of the Gross enrolment ratio (%) of Tertiary schools in 2001 to that in 2007?
Offer a terse response. 0.59. What is the ratio of the Gross enrolment ratio (%) in Pre-primary schools in 2003 to that in 2004?
Offer a very short reply. 0.92. What is the ratio of the Gross enrolment ratio (%) of Primary schools in 2003 to that in 2004?
Your answer should be very brief. 1. What is the ratio of the Gross enrolment ratio (%) of Secondary schools in 2003 to that in 2004?
Make the answer very short. 0.79. What is the ratio of the Gross enrolment ratio (%) in Tertiary schools in 2003 to that in 2004?
Keep it short and to the point. 0.98. What is the ratio of the Gross enrolment ratio (%) of Pre-primary schools in 2003 to that in 2005?
Give a very brief answer. 0.9. What is the ratio of the Gross enrolment ratio (%) in Primary schools in 2003 to that in 2005?
Offer a terse response. 0.98. What is the ratio of the Gross enrolment ratio (%) in Secondary schools in 2003 to that in 2005?
Give a very brief answer. 0.73. What is the ratio of the Gross enrolment ratio (%) of Tertiary schools in 2003 to that in 2005?
Your answer should be very brief. 0.61. What is the ratio of the Gross enrolment ratio (%) in Pre-primary schools in 2003 to that in 2007?
Keep it short and to the point. 0.95. What is the ratio of the Gross enrolment ratio (%) of Primary schools in 2003 to that in 2007?
Your answer should be compact. 0.98. What is the ratio of the Gross enrolment ratio (%) in Secondary schools in 2003 to that in 2007?
Your answer should be very brief. 0.71. What is the ratio of the Gross enrolment ratio (%) in Tertiary schools in 2003 to that in 2007?
Offer a very short reply. 0.6. What is the ratio of the Gross enrolment ratio (%) of Pre-primary schools in 2004 to that in 2005?
Offer a terse response. 0.98. What is the ratio of the Gross enrolment ratio (%) in Primary schools in 2004 to that in 2005?
Give a very brief answer. 0.97. What is the ratio of the Gross enrolment ratio (%) in Secondary schools in 2004 to that in 2005?
Your answer should be very brief. 0.92. What is the ratio of the Gross enrolment ratio (%) in Tertiary schools in 2004 to that in 2005?
Offer a very short reply. 0.62. What is the ratio of the Gross enrolment ratio (%) in Pre-primary schools in 2004 to that in 2007?
Give a very brief answer. 1.03. What is the ratio of the Gross enrolment ratio (%) of Secondary schools in 2004 to that in 2007?
Provide a short and direct response. 0.89. What is the ratio of the Gross enrolment ratio (%) of Tertiary schools in 2004 to that in 2007?
Keep it short and to the point. 0.61. What is the ratio of the Gross enrolment ratio (%) in Pre-primary schools in 2005 to that in 2007?
Your answer should be very brief. 1.06. What is the ratio of the Gross enrolment ratio (%) of Primary schools in 2005 to that in 2007?
Offer a very short reply. 1. What is the ratio of the Gross enrolment ratio (%) of Secondary schools in 2005 to that in 2007?
Your answer should be compact. 0.97. What is the ratio of the Gross enrolment ratio (%) of Tertiary schools in 2005 to that in 2007?
Keep it short and to the point. 0.99. What is the difference between the highest and the second highest Gross enrolment ratio (%) of Pre-primary schools?
Provide a succinct answer. 2.12. What is the difference between the highest and the second highest Gross enrolment ratio (%) in Primary schools?
Make the answer very short. 0.12. What is the difference between the highest and the second highest Gross enrolment ratio (%) in Secondary schools?
Your response must be concise. 2.29. What is the difference between the highest and the second highest Gross enrolment ratio (%) in Tertiary schools?
Ensure brevity in your answer.  0.05. What is the difference between the highest and the lowest Gross enrolment ratio (%) in Pre-primary schools?
Your response must be concise. 79.48. What is the difference between the highest and the lowest Gross enrolment ratio (%) of Primary schools?
Give a very brief answer. 3.03. What is the difference between the highest and the lowest Gross enrolment ratio (%) in Secondary schools?
Give a very brief answer. 35.32. What is the difference between the highest and the lowest Gross enrolment ratio (%) in Tertiary schools?
Your answer should be very brief. 1.94. 